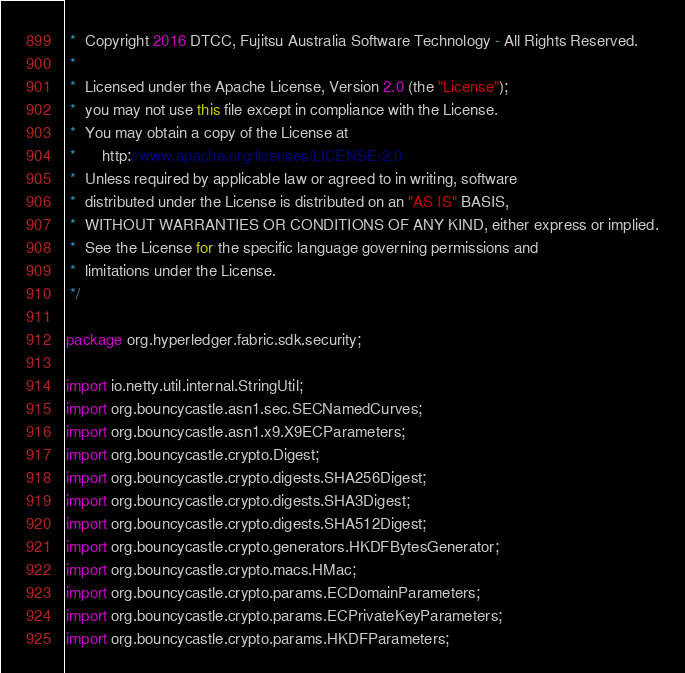<code> <loc_0><loc_0><loc_500><loc_500><_Java_> *  Copyright 2016 DTCC, Fujitsu Australia Software Technology - All Rights Reserved.
 *
 *  Licensed under the Apache License, Version 2.0 (the "License");
 *  you may not use this file except in compliance with the License.
 *  You may obtain a copy of the License at
 * 	  http://www.apache.org/licenses/LICENSE-2.0
 *  Unless required by applicable law or agreed to in writing, software
 *  distributed under the License is distributed on an "AS IS" BASIS,
 *  WITHOUT WARRANTIES OR CONDITIONS OF ANY KIND, either express or implied.
 *  See the License for the specific language governing permissions and
 *  limitations under the License.
 */

package org.hyperledger.fabric.sdk.security;

import io.netty.util.internal.StringUtil;
import org.bouncycastle.asn1.sec.SECNamedCurves;
import org.bouncycastle.asn1.x9.X9ECParameters;
import org.bouncycastle.crypto.Digest;
import org.bouncycastle.crypto.digests.SHA256Digest;
import org.bouncycastle.crypto.digests.SHA3Digest;
import org.bouncycastle.crypto.digests.SHA512Digest;
import org.bouncycastle.crypto.generators.HKDFBytesGenerator;
import org.bouncycastle.crypto.macs.HMac;
import org.bouncycastle.crypto.params.ECDomainParameters;
import org.bouncycastle.crypto.params.ECPrivateKeyParameters;
import org.bouncycastle.crypto.params.HKDFParameters;</code> 